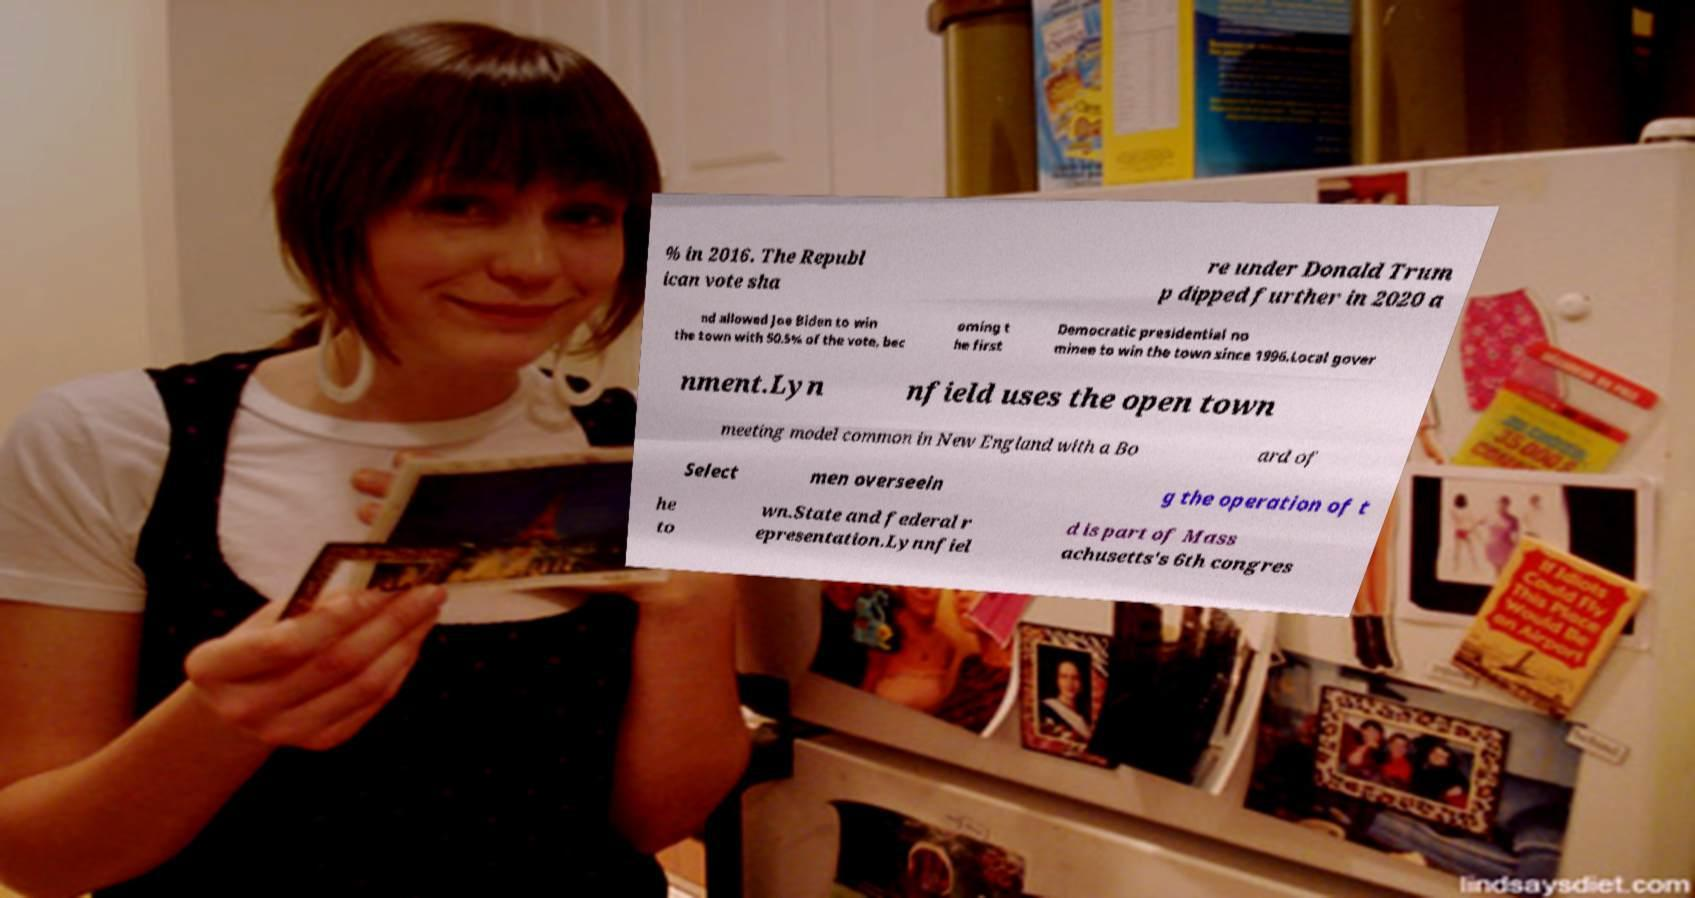Could you extract and type out the text from this image? % in 2016. The Republ ican vote sha re under Donald Trum p dipped further in 2020 a nd allowed Joe Biden to win the town with 50.5% of the vote, bec oming t he first Democratic presidential no minee to win the town since 1996.Local gover nment.Lyn nfield uses the open town meeting model common in New England with a Bo ard of Select men overseein g the operation of t he to wn.State and federal r epresentation.Lynnfiel d is part of Mass achusetts's 6th congres 